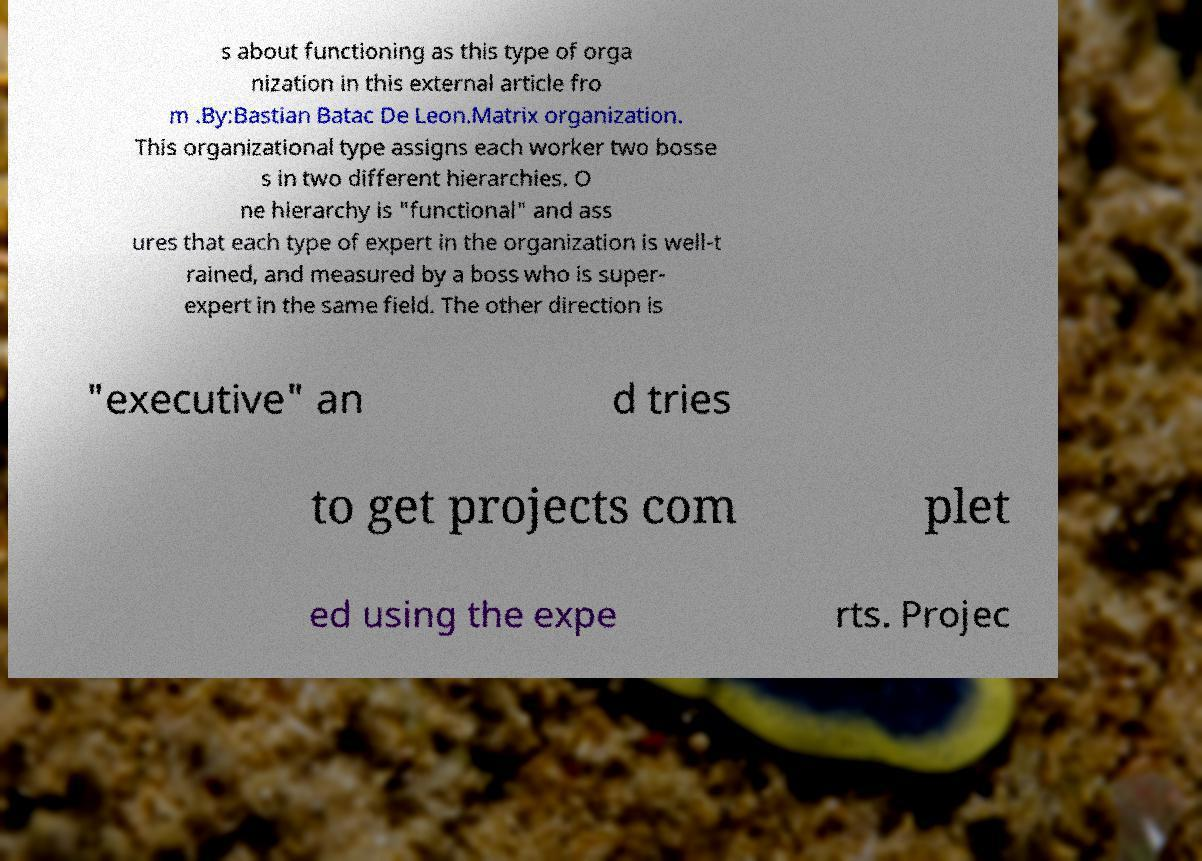Please identify and transcribe the text found in this image. s about functioning as this type of orga nization in this external article fro m .By:Bastian Batac De Leon.Matrix organization. This organizational type assigns each worker two bosse s in two different hierarchies. O ne hierarchy is "functional" and ass ures that each type of expert in the organization is well-t rained, and measured by a boss who is super- expert in the same field. The other direction is "executive" an d tries to get projects com plet ed using the expe rts. Projec 